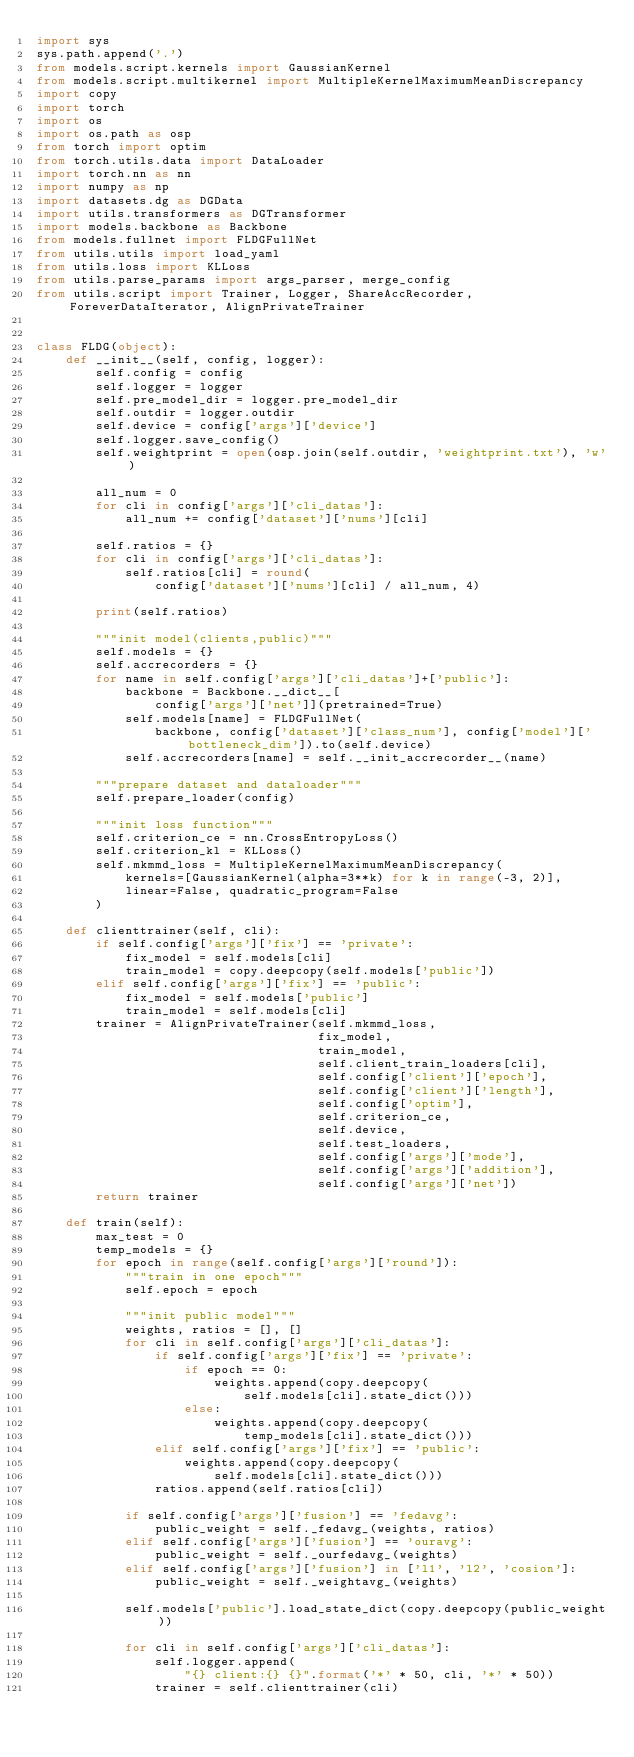<code> <loc_0><loc_0><loc_500><loc_500><_Python_>import sys
sys.path.append('.')
from models.script.kernels import GaussianKernel
from models.script.multikernel import MultipleKernelMaximumMeanDiscrepancy
import copy
import torch
import os
import os.path as osp
from torch import optim
from torch.utils.data import DataLoader
import torch.nn as nn
import numpy as np
import datasets.dg as DGData
import utils.transformers as DGTransformer
import models.backbone as Backbone
from models.fullnet import FLDGFullNet
from utils.utils import load_yaml
from utils.loss import KLLoss
from utils.parse_params import args_parser, merge_config
from utils.script import Trainer, Logger, ShareAccRecorder, ForeverDataIterator, AlignPrivateTrainer


class FLDG(object):
    def __init__(self, config, logger):
        self.config = config
        self.logger = logger
        self.pre_model_dir = logger.pre_model_dir
        self.outdir = logger.outdir
        self.device = config['args']['device']
        self.logger.save_config()
        self.weightprint = open(osp.join(self.outdir, 'weightprint.txt'), 'w')

        all_num = 0
        for cli in config['args']['cli_datas']:
            all_num += config['dataset']['nums'][cli]

        self.ratios = {}
        for cli in config['args']['cli_datas']:
            self.ratios[cli] = round(
                config['dataset']['nums'][cli] / all_num, 4)

        print(self.ratios)

        """init model(clients,public)"""
        self.models = {}
        self.accrecorders = {}
        for name in self.config['args']['cli_datas']+['public']:
            backbone = Backbone.__dict__[
                config['args']['net']](pretrained=True)
            self.models[name] = FLDGFullNet(
                backbone, config['dataset']['class_num'], config['model']['bottleneck_dim']).to(self.device)
            self.accrecorders[name] = self.__init_accrecorder__(name)

        """prepare dataset and dataloader"""
        self.prepare_loader(config)

        """init loss function"""
        self.criterion_ce = nn.CrossEntropyLoss()
        self.criterion_kl = KLLoss()
        self.mkmmd_loss = MultipleKernelMaximumMeanDiscrepancy(
            kernels=[GaussianKernel(alpha=3**k) for k in range(-3, 2)],
            linear=False, quadratic_program=False
        )

    def clienttrainer(self, cli):
        if self.config['args']['fix'] == 'private':
            fix_model = self.models[cli]
            train_model = copy.deepcopy(self.models['public'])
        elif self.config['args']['fix'] == 'public':
            fix_model = self.models['public']
            train_model = self.models[cli]
        trainer = AlignPrivateTrainer(self.mkmmd_loss,
                                      fix_model,
                                      train_model,
                                      self.client_train_loaders[cli],
                                      self.config['client']['epoch'],
                                      self.config['client']['length'],
                                      self.config['optim'],
                                      self.criterion_ce,
                                      self.device,
                                      self.test_loaders,
                                      self.config['args']['mode'],
                                      self.config['args']['addition'],
                                      self.config['args']['net'])
        return trainer

    def train(self):
        max_test = 0
        temp_models = {}
        for epoch in range(self.config['args']['round']):
            """train in one epoch"""
            self.epoch = epoch

            """init public model"""
            weights, ratios = [], []
            for cli in self.config['args']['cli_datas']:
                if self.config['args']['fix'] == 'private':
                    if epoch == 0:
                        weights.append(copy.deepcopy(
                            self.models[cli].state_dict()))
                    else:
                        weights.append(copy.deepcopy(
                            temp_models[cli].state_dict()))
                elif self.config['args']['fix'] == 'public':
                    weights.append(copy.deepcopy(
                        self.models[cli].state_dict()))
                ratios.append(self.ratios[cli])

            if self.config['args']['fusion'] == 'fedavg':
                public_weight = self._fedavg_(weights, ratios)
            elif self.config['args']['fusion'] == 'ouravg':
                public_weight = self._ourfedavg_(weights)
            elif self.config['args']['fusion'] in ['l1', 'l2', 'cosion']:
                public_weight = self._weightavg_(weights)

            self.models['public'].load_state_dict(copy.deepcopy(public_weight))

            for cli in self.config['args']['cli_datas']:
                self.logger.append(
                    "{} client:{} {}".format('*' * 50, cli, '*' * 50))
                trainer = self.clienttrainer(cli)</code> 